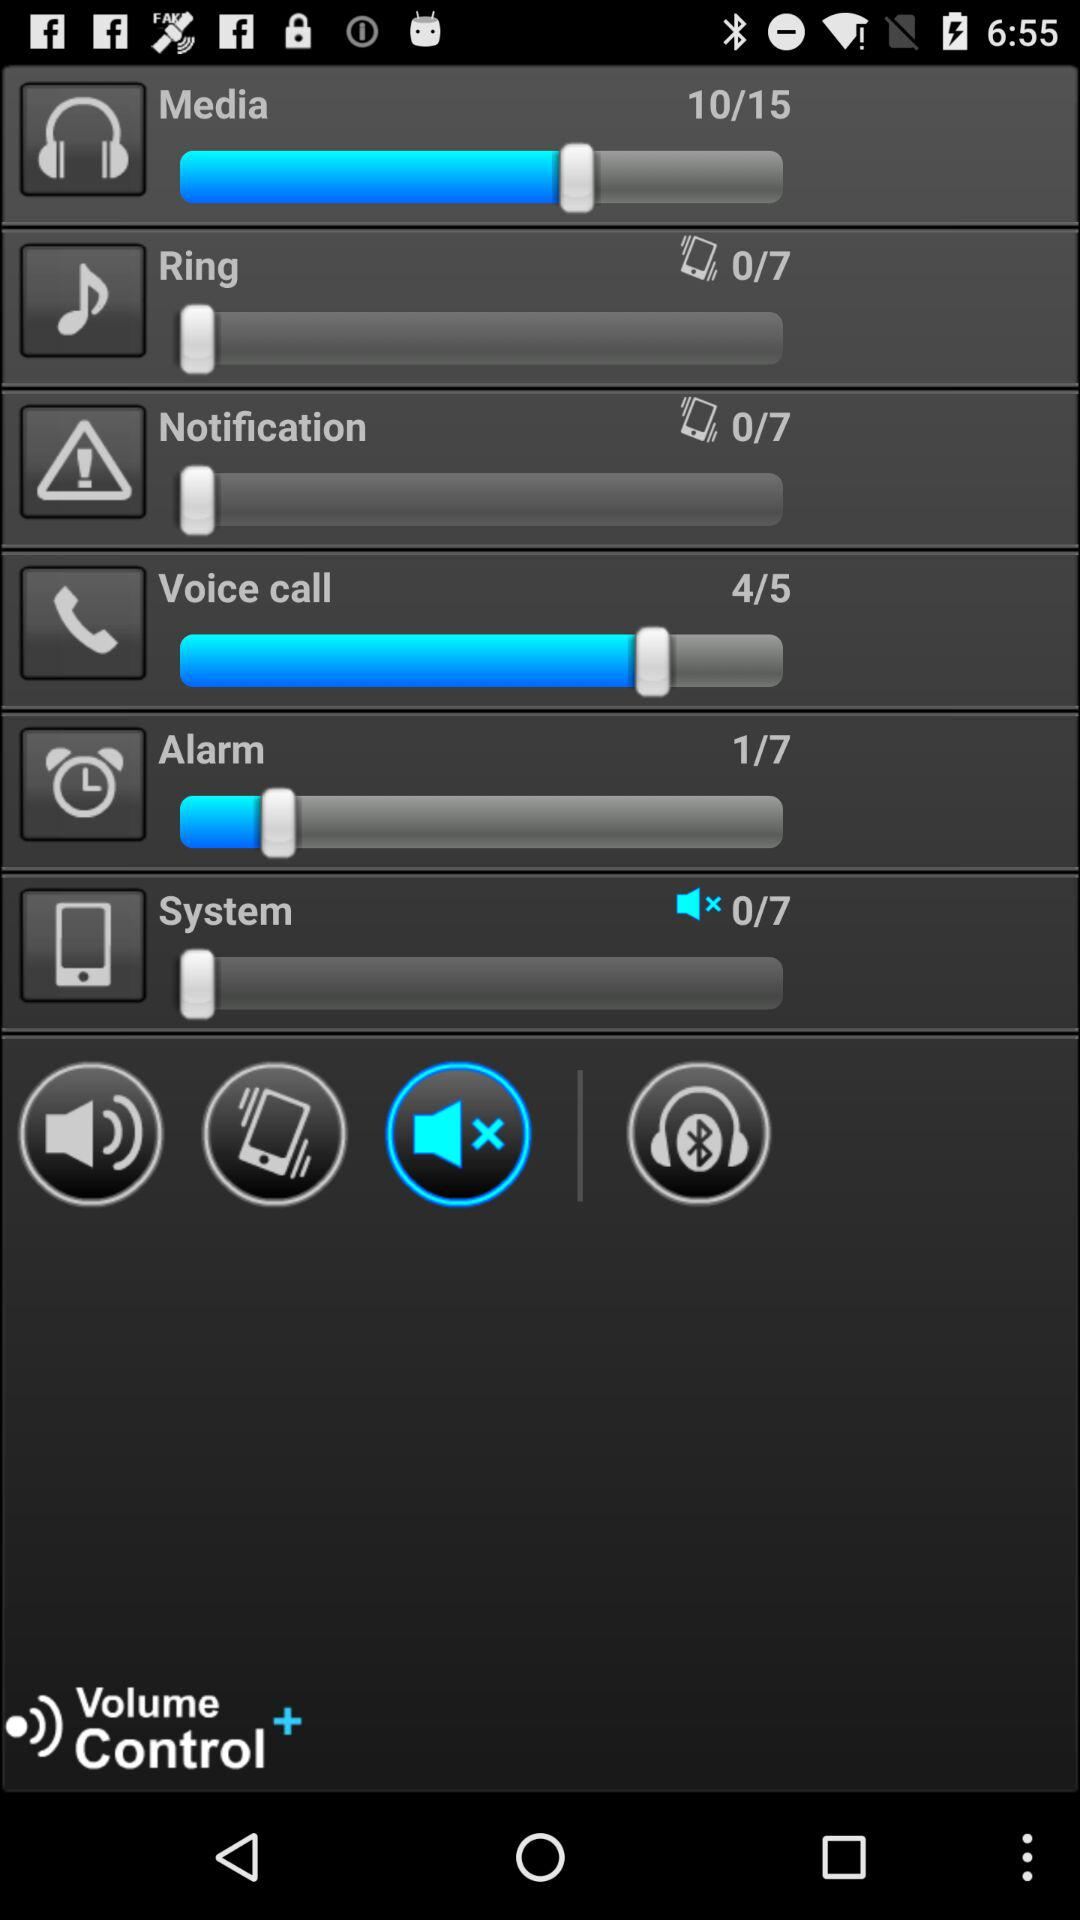What is the selected option? The selected option is "mute". 